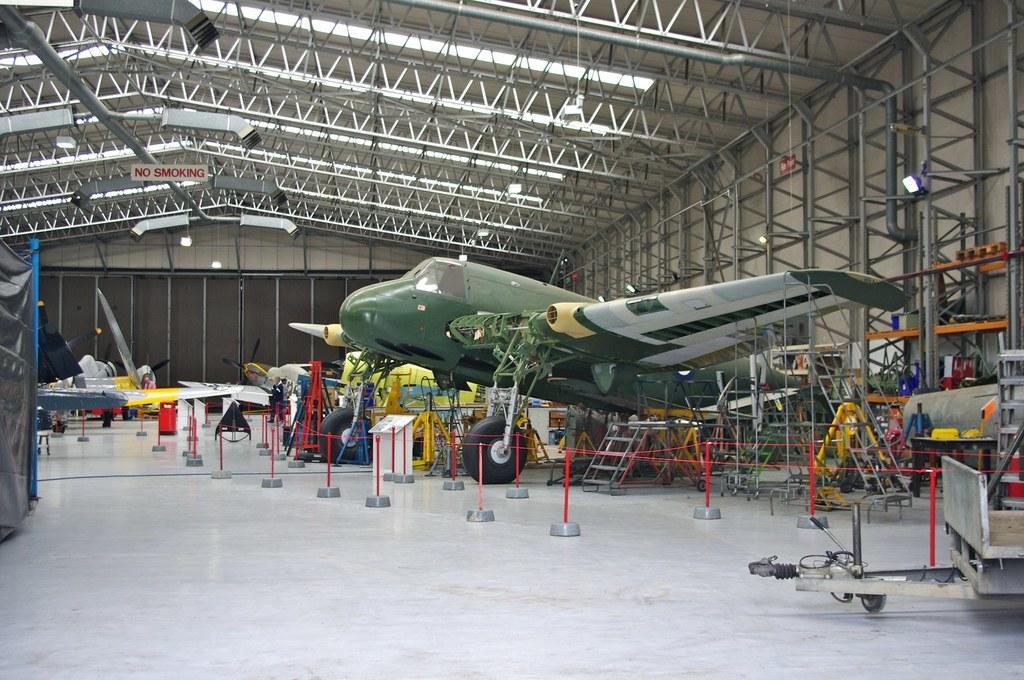<image>
Summarize the visual content of the image. No smoking is allowed in the warehouse that houses is airplane. 